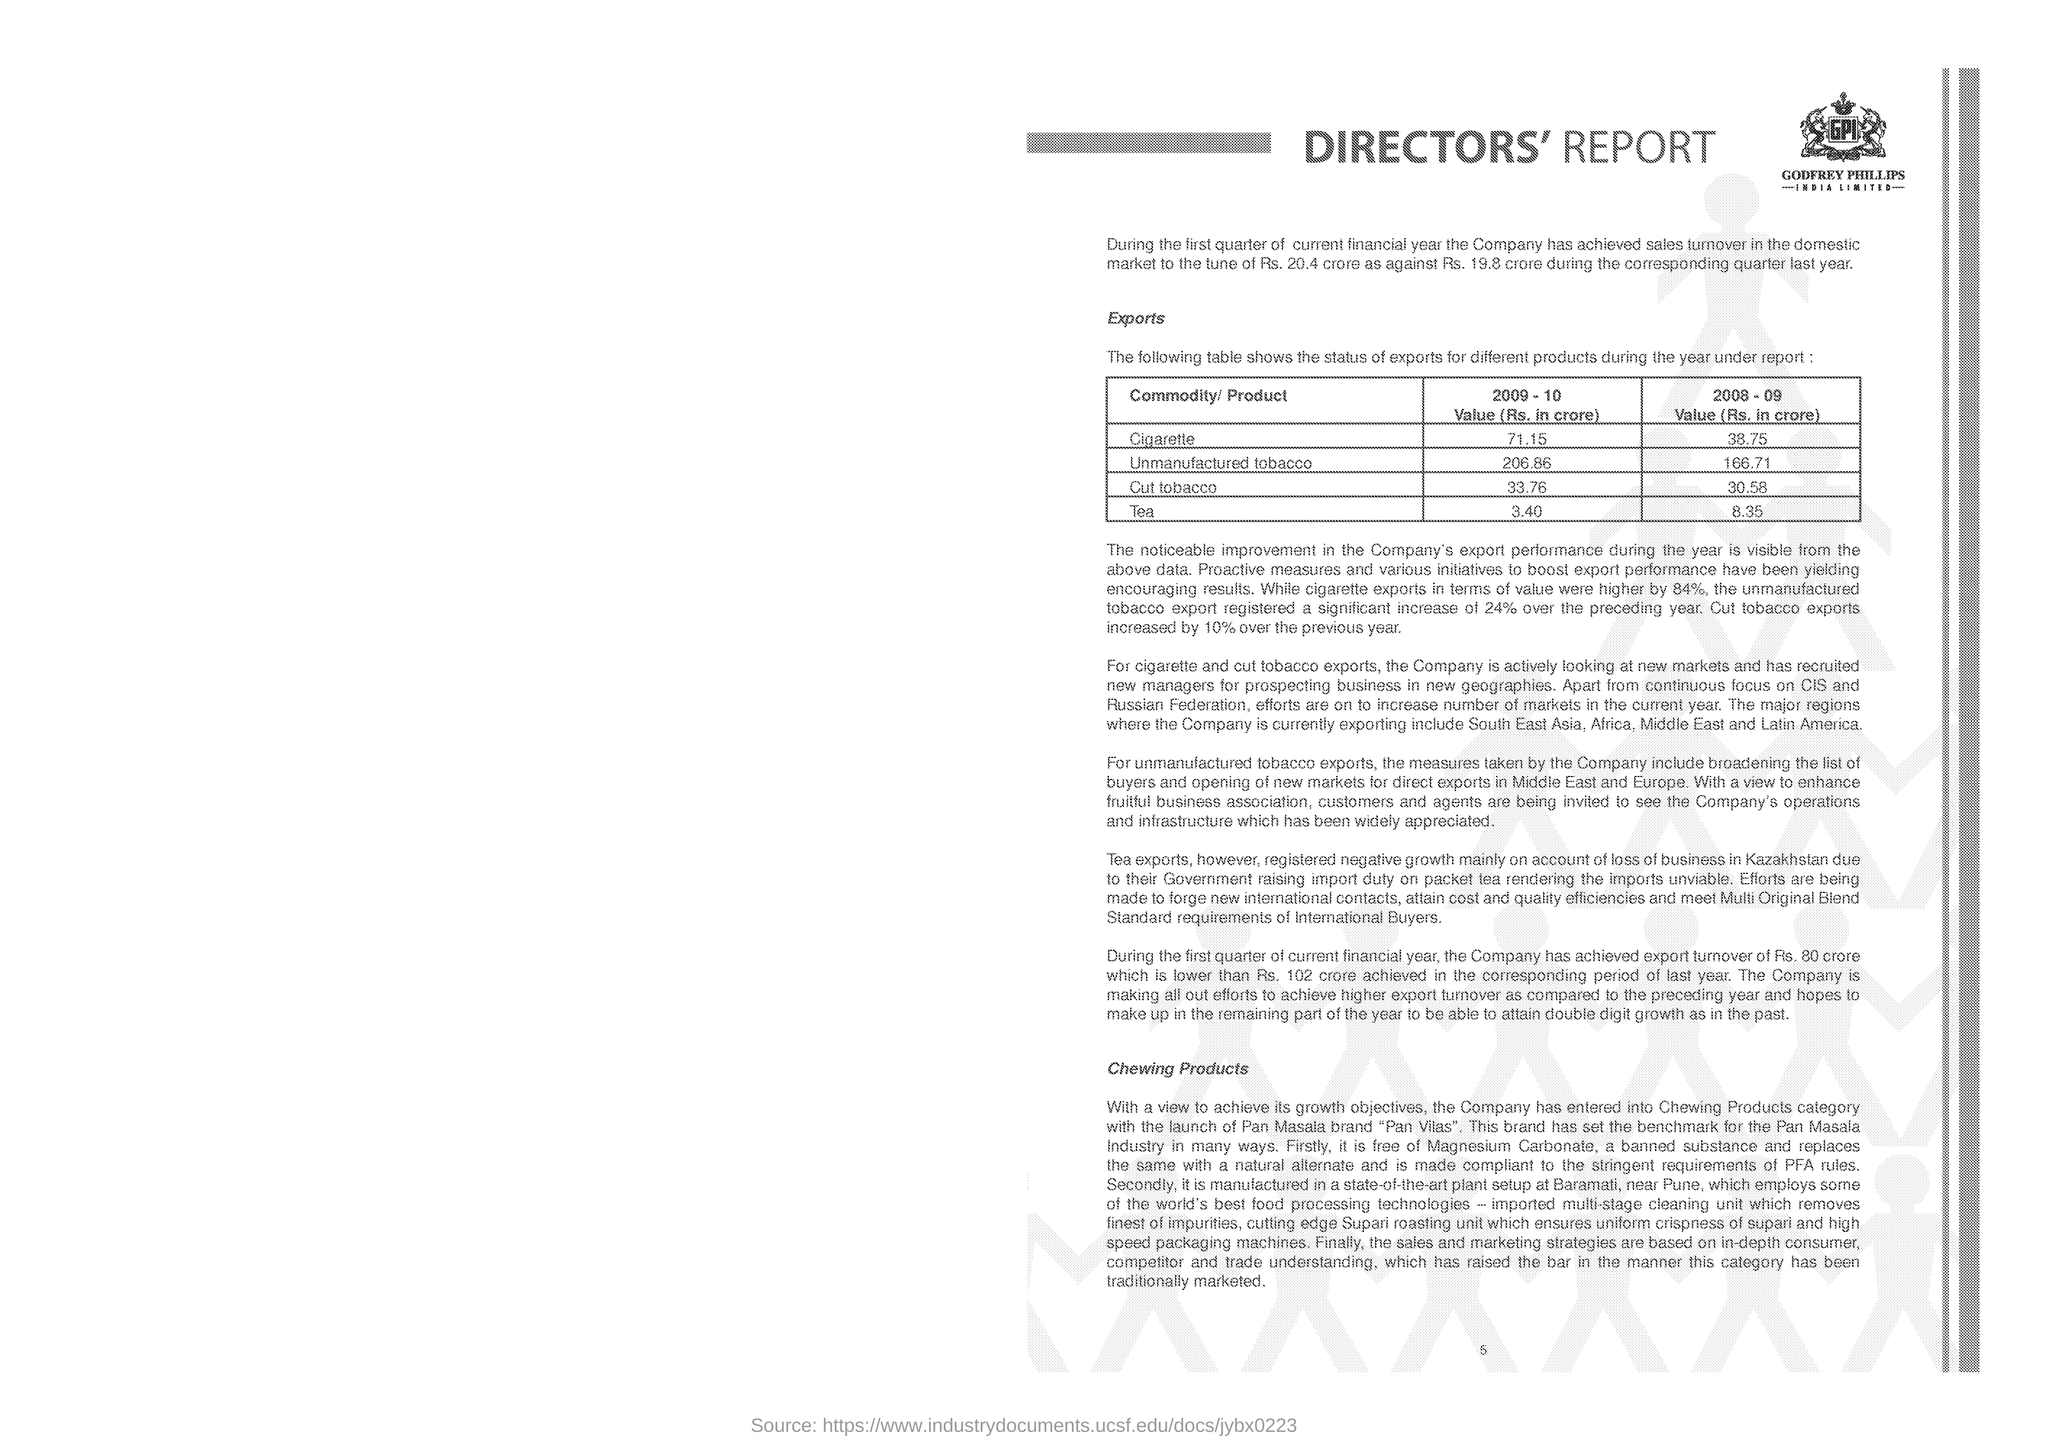What is the export value (Rs. in crore ) in the year 2009-10 for cigarette?
Your answer should be very brief. 71.15. What is the export value (Rs. in crore ) in the year 2008-09 for Tea?
Provide a short and direct response. 8.35. What is the export value (Rs. in crore ) in the year 2009-10 for Unmanufactured tobacco?
Provide a succinct answer. 206.86. What is the export value (Rs. in crore ) in the year 2008-09 for Cut tobacco?
Keep it short and to the point. 30.58. 